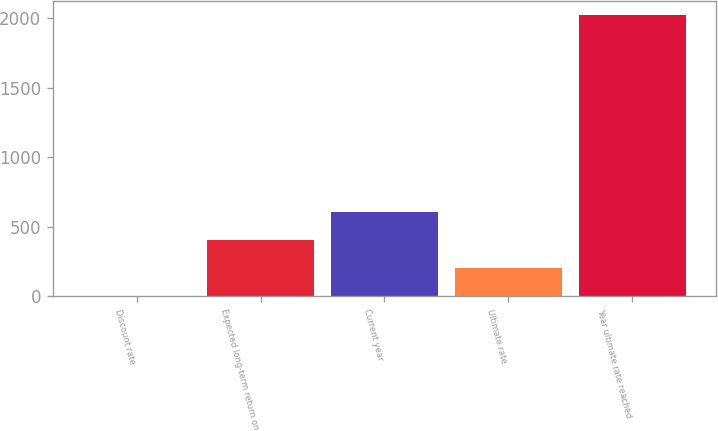Convert chart. <chart><loc_0><loc_0><loc_500><loc_500><bar_chart><fcel>Discount rate<fcel>Expected long-term return on<fcel>Current year<fcel>Ultimate rate<fcel>Year ultimate rate reached<nl><fcel>5.5<fcel>408.2<fcel>609.55<fcel>206.85<fcel>2019<nl></chart> 